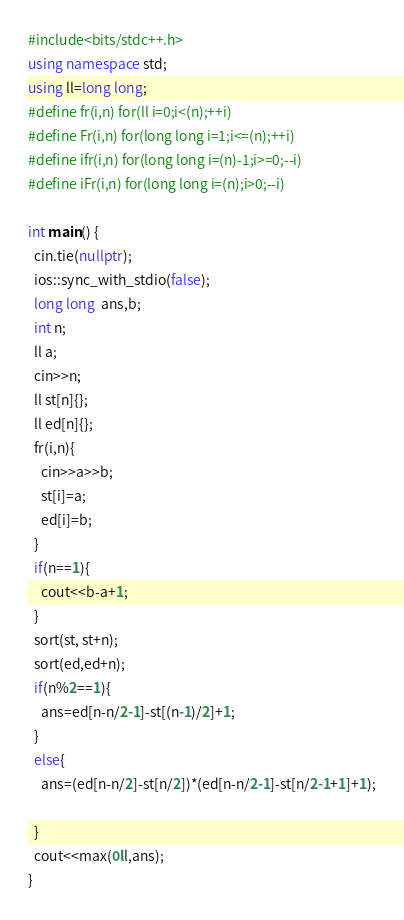<code> <loc_0><loc_0><loc_500><loc_500><_C++_>#include<bits/stdc++.h>
using namespace std;
using ll=long long;
#define fr(i,n) for(ll i=0;i<(n);++i)
#define Fr(i,n) for(long long i=1;i<=(n);++i)
#define ifr(i,n) for(long long i=(n)-1;i>=0;--i)
#define iFr(i,n) for(long long i=(n);i>0;--i)

int main() {
  cin.tie(nullptr);
  ios::sync_with_stdio(false);
  long long  ans,b;
  int n;
  ll a;
  cin>>n;
  ll st[n]{};
  ll ed[n]{};
  fr(i,n){
    cin>>a>>b;
    st[i]=a;
    ed[i]=b;
  }
  if(n==1){
    cout<<b-a+1;
  }
  sort(st, st+n);
  sort(ed,ed+n);
  if(n%2==1){
    ans=ed[n-n/2-1]-st[(n-1)/2]+1;
  }
  else{
    ans=(ed[n-n/2]-st[n/2])*(ed[n-n/2-1]-st[n/2-1+1]+1);
    
  }
  cout<<max(0ll,ans);
}</code> 